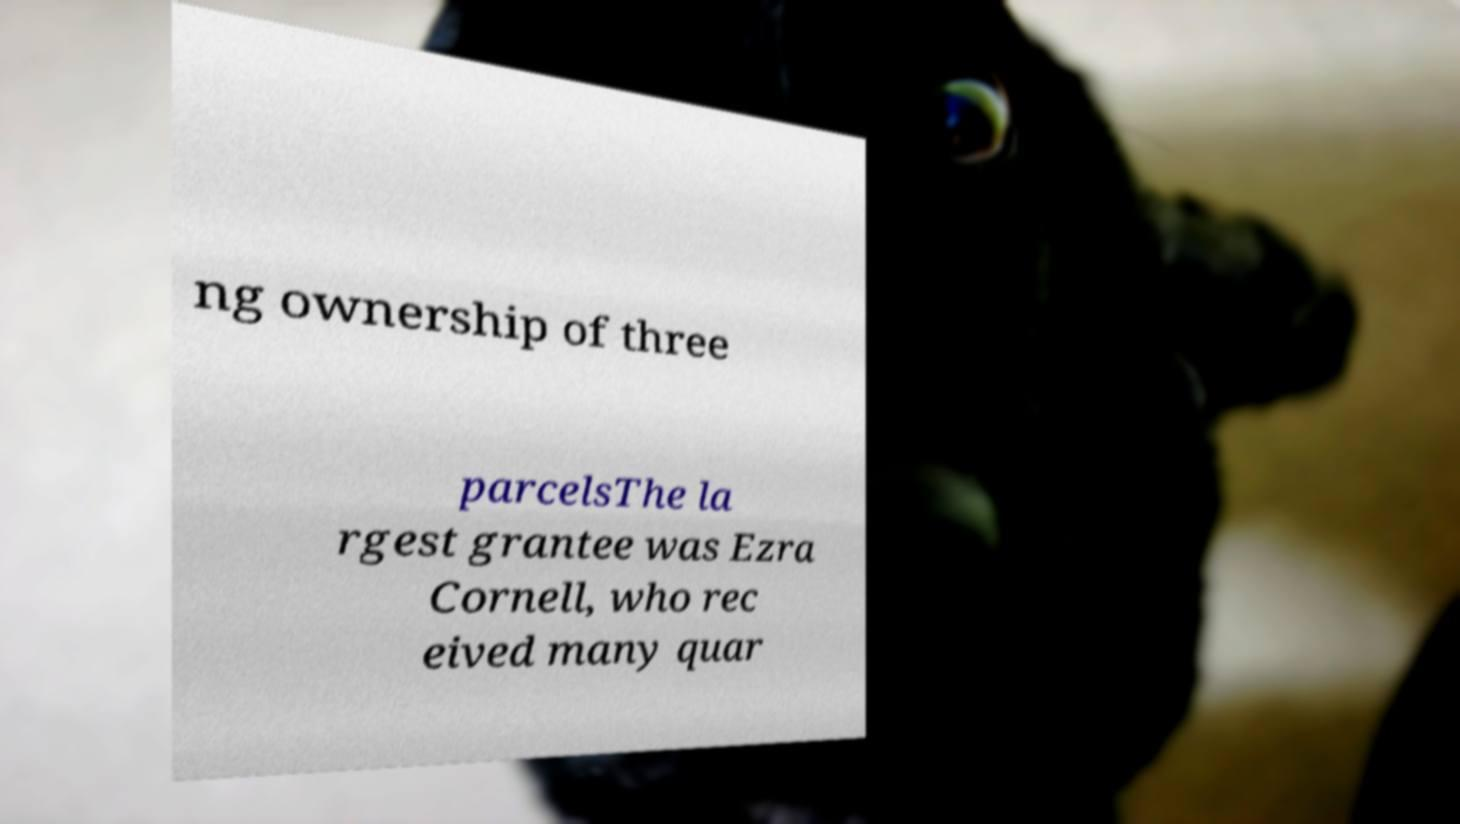Can you read and provide the text displayed in the image?This photo seems to have some interesting text. Can you extract and type it out for me? ng ownership of three parcelsThe la rgest grantee was Ezra Cornell, who rec eived many quar 